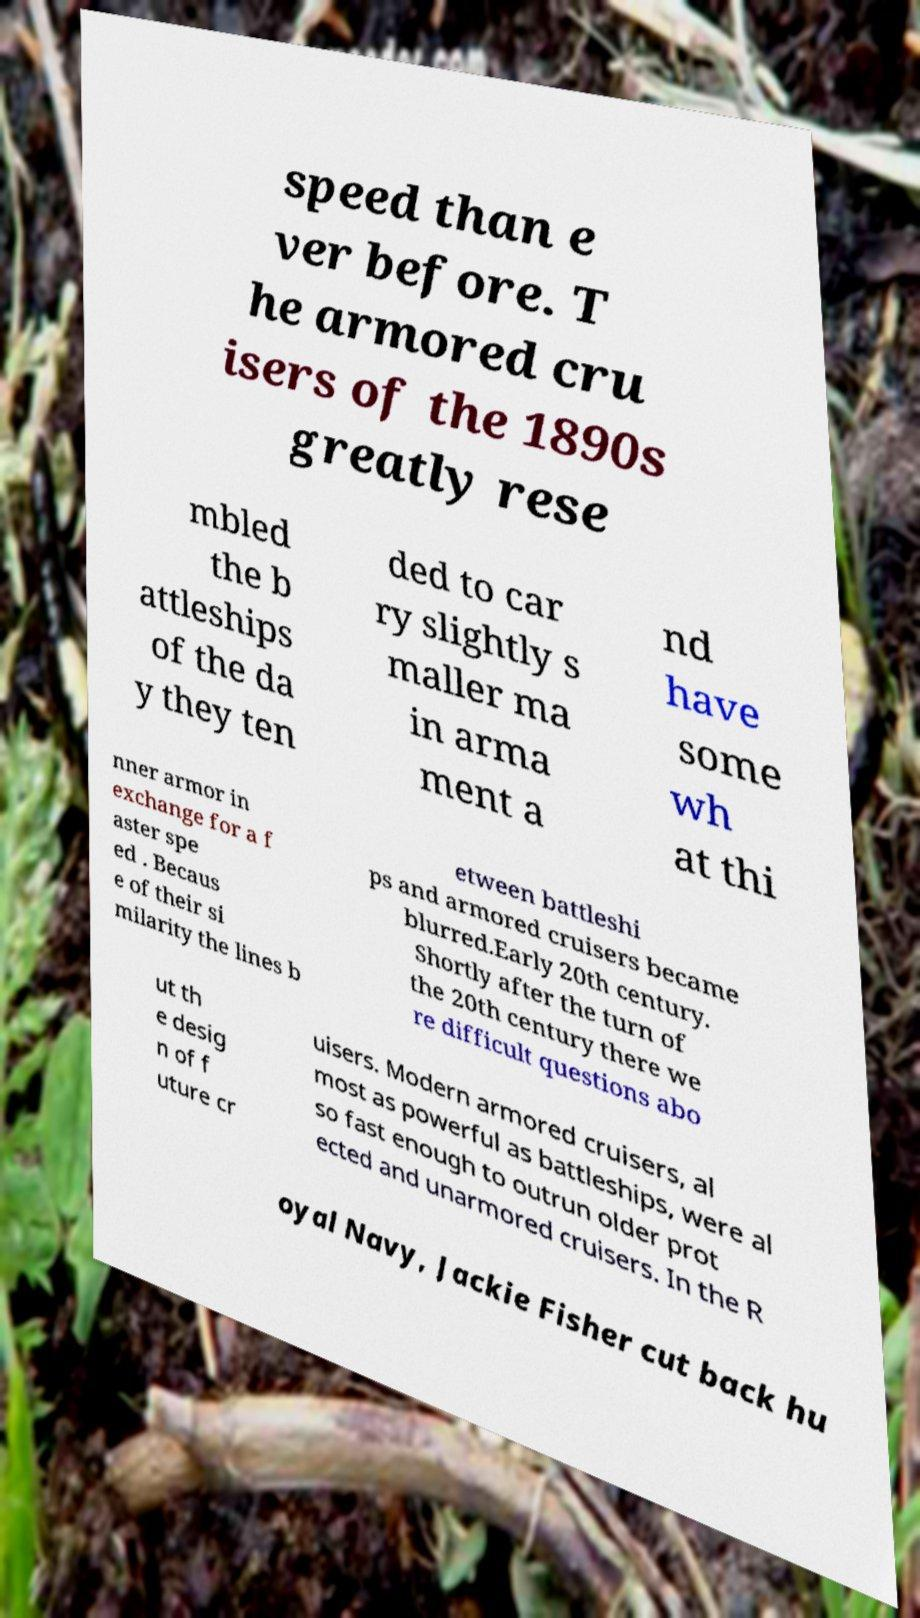I need the written content from this picture converted into text. Can you do that? speed than e ver before. T he armored cru isers of the 1890s greatly rese mbled the b attleships of the da y they ten ded to car ry slightly s maller ma in arma ment a nd have some wh at thi nner armor in exchange for a f aster spe ed . Becaus e of their si milarity the lines b etween battleshi ps and armored cruisers became blurred.Early 20th century. Shortly after the turn of the 20th century there we re difficult questions abo ut th e desig n of f uture cr uisers. Modern armored cruisers, al most as powerful as battleships, were al so fast enough to outrun older prot ected and unarmored cruisers. In the R oyal Navy, Jackie Fisher cut back hu 